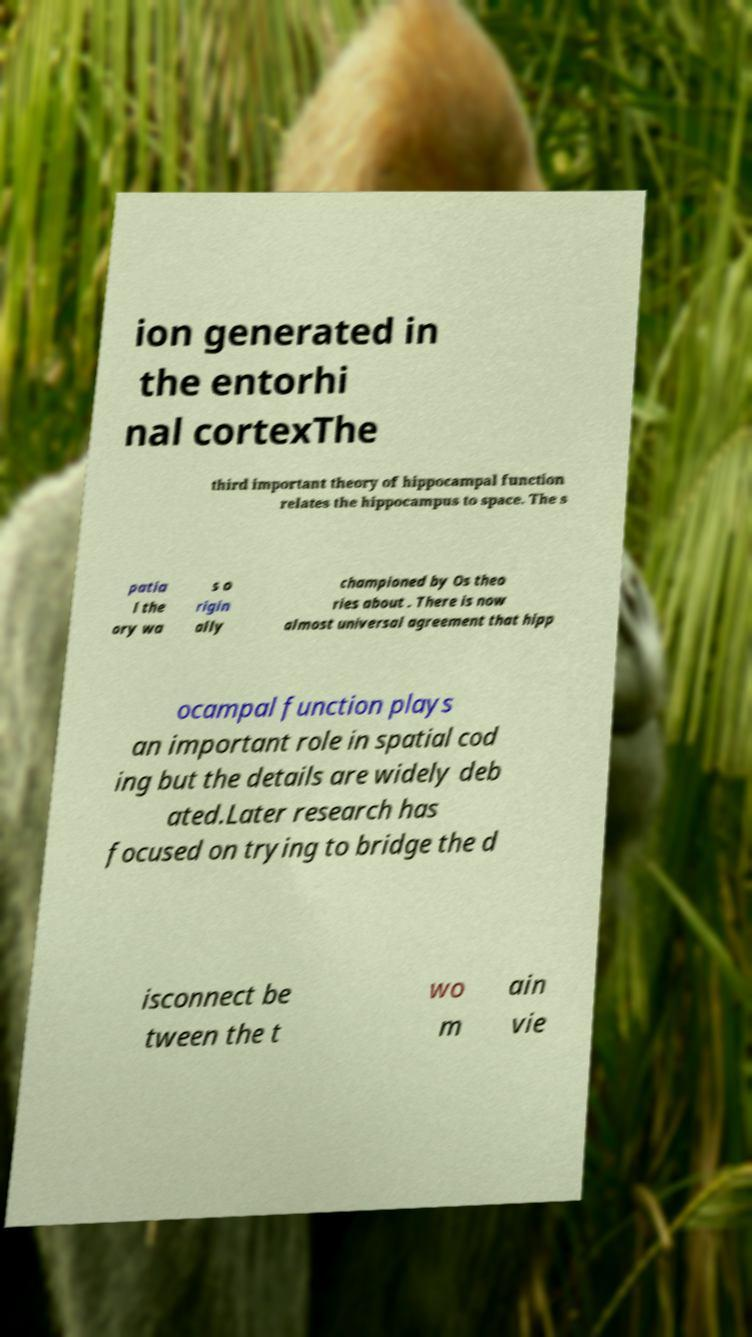Could you assist in decoding the text presented in this image and type it out clearly? ion generated in the entorhi nal cortexThe third important theory of hippocampal function relates the hippocampus to space. The s patia l the ory wa s o rigin ally championed by Os theo ries about . There is now almost universal agreement that hipp ocampal function plays an important role in spatial cod ing but the details are widely deb ated.Later research has focused on trying to bridge the d isconnect be tween the t wo m ain vie 